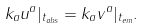Convert formula to latex. <formula><loc_0><loc_0><loc_500><loc_500>k _ { a } u ^ { a } | _ { t _ { o b s } } = k _ { a } v ^ { a } | _ { t _ { e m } } .</formula> 